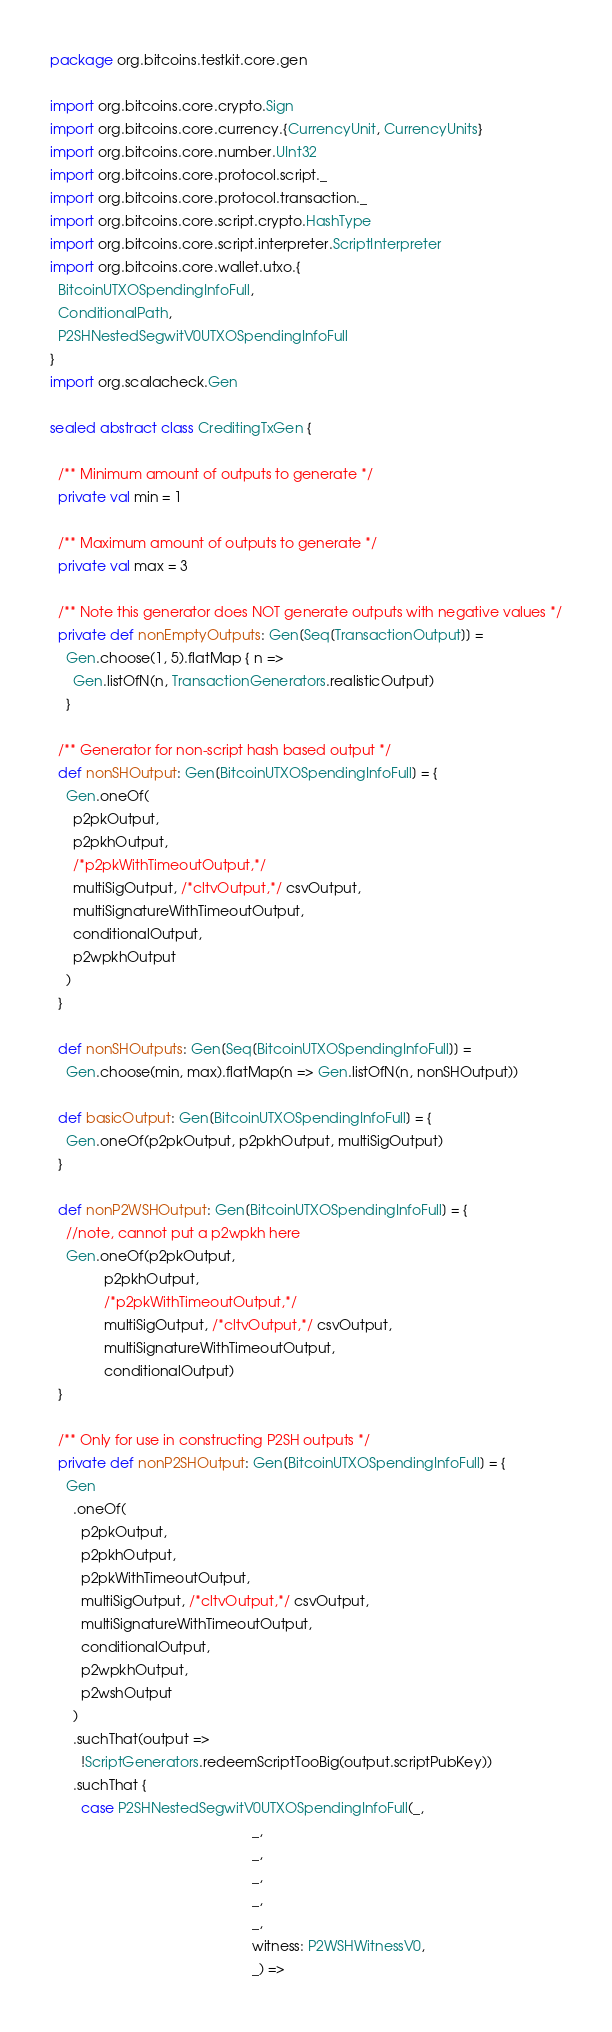<code> <loc_0><loc_0><loc_500><loc_500><_Scala_>package org.bitcoins.testkit.core.gen

import org.bitcoins.core.crypto.Sign
import org.bitcoins.core.currency.{CurrencyUnit, CurrencyUnits}
import org.bitcoins.core.number.UInt32
import org.bitcoins.core.protocol.script._
import org.bitcoins.core.protocol.transaction._
import org.bitcoins.core.script.crypto.HashType
import org.bitcoins.core.script.interpreter.ScriptInterpreter
import org.bitcoins.core.wallet.utxo.{
  BitcoinUTXOSpendingInfoFull,
  ConditionalPath,
  P2SHNestedSegwitV0UTXOSpendingInfoFull
}
import org.scalacheck.Gen

sealed abstract class CreditingTxGen {

  /** Minimum amount of outputs to generate */
  private val min = 1

  /** Maximum amount of outputs to generate */
  private val max = 3

  /** Note this generator does NOT generate outputs with negative values */
  private def nonEmptyOutputs: Gen[Seq[TransactionOutput]] =
    Gen.choose(1, 5).flatMap { n =>
      Gen.listOfN(n, TransactionGenerators.realisticOutput)
    }

  /** Generator for non-script hash based output */
  def nonSHOutput: Gen[BitcoinUTXOSpendingInfoFull] = {
    Gen.oneOf(
      p2pkOutput,
      p2pkhOutput,
      /*p2pkWithTimeoutOutput,*/
      multiSigOutput, /*cltvOutput,*/ csvOutput,
      multiSignatureWithTimeoutOutput,
      conditionalOutput,
      p2wpkhOutput
    )
  }

  def nonSHOutputs: Gen[Seq[BitcoinUTXOSpendingInfoFull]] =
    Gen.choose(min, max).flatMap(n => Gen.listOfN(n, nonSHOutput))

  def basicOutput: Gen[BitcoinUTXOSpendingInfoFull] = {
    Gen.oneOf(p2pkOutput, p2pkhOutput, multiSigOutput)
  }

  def nonP2WSHOutput: Gen[BitcoinUTXOSpendingInfoFull] = {
    //note, cannot put a p2wpkh here
    Gen.oneOf(p2pkOutput,
              p2pkhOutput,
              /*p2pkWithTimeoutOutput,*/
              multiSigOutput, /*cltvOutput,*/ csvOutput,
              multiSignatureWithTimeoutOutput,
              conditionalOutput)
  }

  /** Only for use in constructing P2SH outputs */
  private def nonP2SHOutput: Gen[BitcoinUTXOSpendingInfoFull] = {
    Gen
      .oneOf(
        p2pkOutput,
        p2pkhOutput,
        p2pkWithTimeoutOutput,
        multiSigOutput, /*cltvOutput,*/ csvOutput,
        multiSignatureWithTimeoutOutput,
        conditionalOutput,
        p2wpkhOutput,
        p2wshOutput
      )
      .suchThat(output =>
        !ScriptGenerators.redeemScriptTooBig(output.scriptPubKey))
      .suchThat {
        case P2SHNestedSegwitV0UTXOSpendingInfoFull(_,
                                                    _,
                                                    _,
                                                    _,
                                                    _,
                                                    _,
                                                    witness: P2WSHWitnessV0,
                                                    _) =></code> 